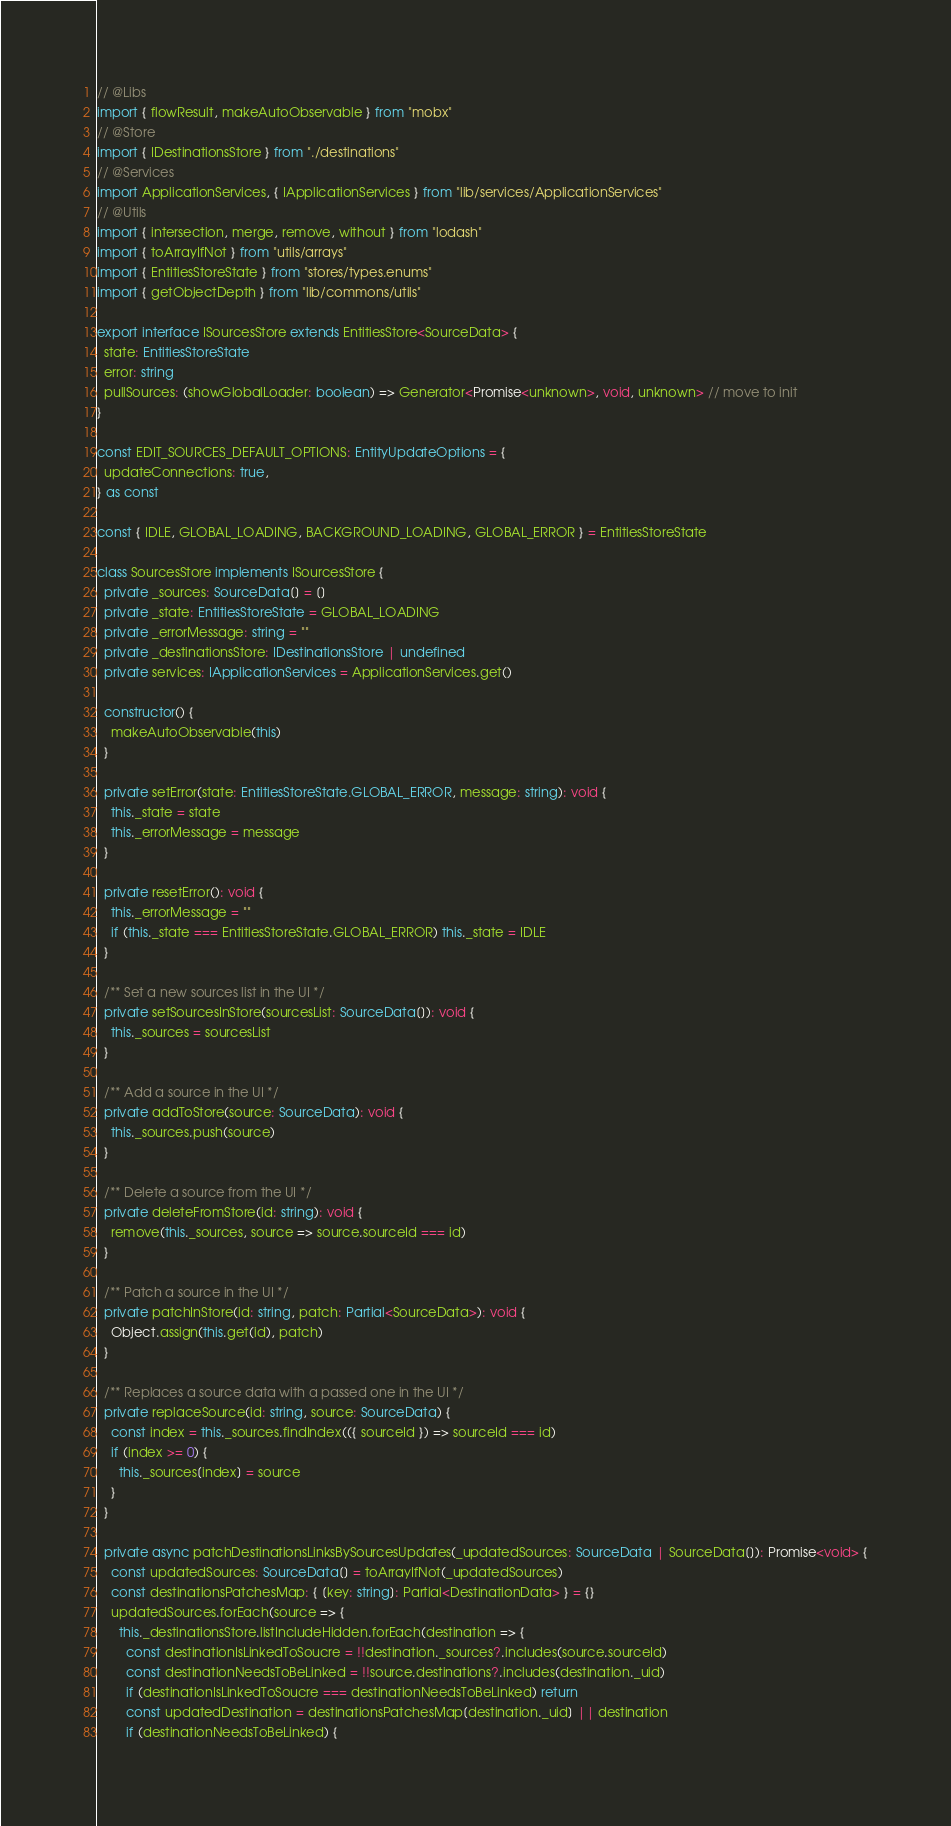<code> <loc_0><loc_0><loc_500><loc_500><_TypeScript_>// @Libs
import { flowResult, makeAutoObservable } from "mobx"
// @Store
import { IDestinationsStore } from "./destinations"
// @Services
import ApplicationServices, { IApplicationServices } from "lib/services/ApplicationServices"
// @Utils
import { intersection, merge, remove, without } from "lodash"
import { toArrayIfNot } from "utils/arrays"
import { EntitiesStoreState } from "stores/types.enums"
import { getObjectDepth } from "lib/commons/utils"

export interface ISourcesStore extends EntitiesStore<SourceData> {
  state: EntitiesStoreState
  error: string
  pullSources: (showGlobalLoader: boolean) => Generator<Promise<unknown>, void, unknown> // move to init
}

const EDIT_SOURCES_DEFAULT_OPTIONS: EntityUpdateOptions = {
  updateConnections: true,
} as const

const { IDLE, GLOBAL_LOADING, BACKGROUND_LOADING, GLOBAL_ERROR } = EntitiesStoreState

class SourcesStore implements ISourcesStore {
  private _sources: SourceData[] = []
  private _state: EntitiesStoreState = GLOBAL_LOADING
  private _errorMessage: string = ""
  private _destinationsStore: IDestinationsStore | undefined
  private services: IApplicationServices = ApplicationServices.get()

  constructor() {
    makeAutoObservable(this)
  }

  private setError(state: EntitiesStoreState.GLOBAL_ERROR, message: string): void {
    this._state = state
    this._errorMessage = message
  }

  private resetError(): void {
    this._errorMessage = ""
    if (this._state === EntitiesStoreState.GLOBAL_ERROR) this._state = IDLE
  }

  /** Set a new sources list in the UI */
  private setSourcesInStore(sourcesList: SourceData[]): void {
    this._sources = sourcesList
  }

  /** Add a source in the UI */
  private addToStore(source: SourceData): void {
    this._sources.push(source)
  }

  /** Delete a source from the UI */
  private deleteFromStore(id: string): void {
    remove(this._sources, source => source.sourceId === id)
  }

  /** Patch a source in the UI */
  private patchInStore(id: string, patch: Partial<SourceData>): void {
    Object.assign(this.get(id), patch)
  }

  /** Replaces a source data with a passed one in the UI */
  private replaceSource(id: string, source: SourceData) {
    const index = this._sources.findIndex(({ sourceId }) => sourceId === id)
    if (index >= 0) {
      this._sources[index] = source
    }
  }

  private async patchDestinationsLinksBySourcesUpdates(_updatedSources: SourceData | SourceData[]): Promise<void> {
    const updatedSources: SourceData[] = toArrayIfNot(_updatedSources)
    const destinationsPatchesMap: { [key: string]: Partial<DestinationData> } = {}
    updatedSources.forEach(source => {
      this._destinationsStore.listIncludeHidden.forEach(destination => {
        const destinationIsLinkedToSoucre = !!destination._sources?.includes(source.sourceId)
        const destinationNeedsToBeLinked = !!source.destinations?.includes(destination._uid)
        if (destinationIsLinkedToSoucre === destinationNeedsToBeLinked) return
        const updatedDestination = destinationsPatchesMap[destination._uid] || destination
        if (destinationNeedsToBeLinked) {</code> 